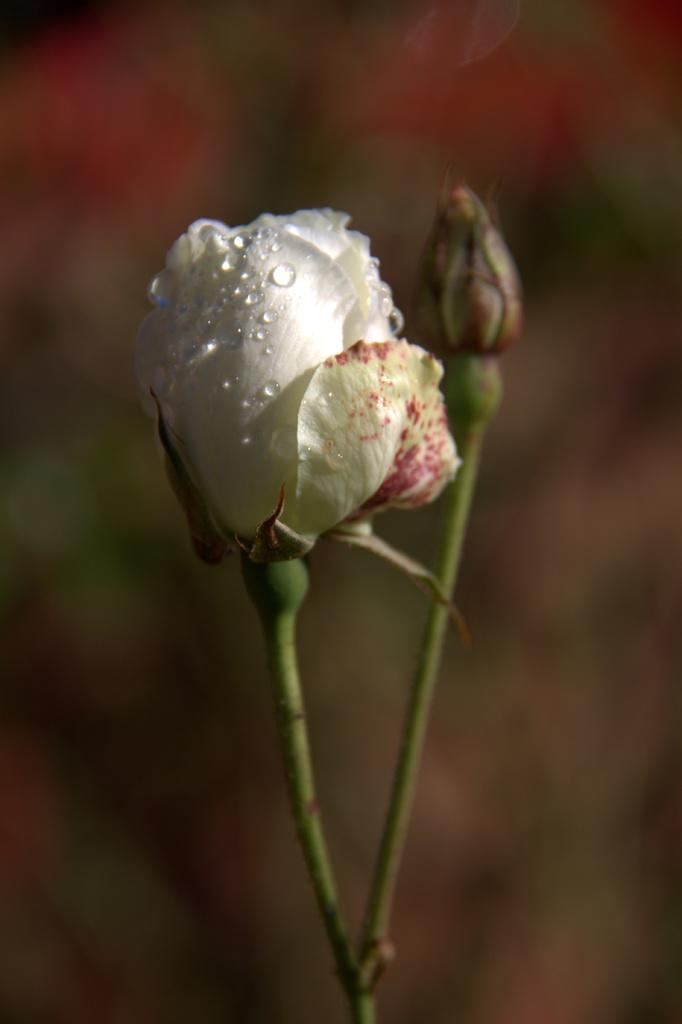What is located in the foreground of the image? There is a flower in the foreground of the image. What can be seen in the background of the image? There are plants in the background of the image. What type of jar is visible in the image? There is no jar present in the image. Can you see the chin of the person in the image? There is no person present in the image, so it is not possible to see their chin. What part of the brain is visible in the image? There is no brain present in the image, so it is not possible to see any part of a brain. 